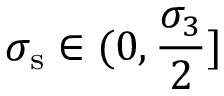<formula> <loc_0><loc_0><loc_500><loc_500>\sigma _ { s } \in ( 0 , \frac { \sigma _ { 3 } } { 2 } ]</formula> 